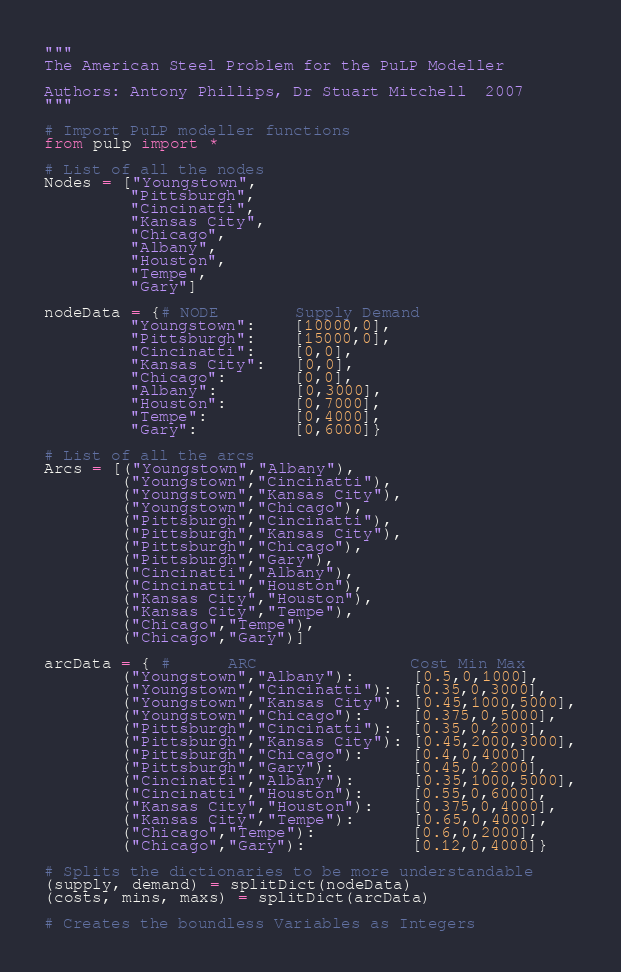Convert code to text. <code><loc_0><loc_0><loc_500><loc_500><_Python_>"""
The American Steel Problem for the PuLP Modeller

Authors: Antony Phillips, Dr Stuart Mitchell  2007
"""

# Import PuLP modeller functions
from pulp import *

# List of all the nodes
Nodes = ["Youngstown",
         "Pittsburgh",
         "Cincinatti",
         "Kansas City",
         "Chicago",
         "Albany",
         "Houston",
         "Tempe",
         "Gary"]

nodeData = {# NODE        Supply Demand
         "Youngstown":    [10000,0],
         "Pittsburgh":    [15000,0],
         "Cincinatti":    [0,0],
         "Kansas City":   [0,0],
         "Chicago":       [0,0],
         "Albany":        [0,3000],
         "Houston":       [0,7000],
         "Tempe":         [0,4000],
         "Gary":          [0,6000]}

# List of all the arcs
Arcs = [("Youngstown","Albany"),
        ("Youngstown","Cincinatti"),
        ("Youngstown","Kansas City"),
        ("Youngstown","Chicago"),
        ("Pittsburgh","Cincinatti"),
        ("Pittsburgh","Kansas City"),
        ("Pittsburgh","Chicago"),
        ("Pittsburgh","Gary"),
        ("Cincinatti","Albany"),
        ("Cincinatti","Houston"),
        ("Kansas City","Houston"),
        ("Kansas City","Tempe"),
        ("Chicago","Tempe"),
        ("Chicago","Gary")]

arcData = { #      ARC                Cost Min Max
        ("Youngstown","Albany"):      [0.5,0,1000],
        ("Youngstown","Cincinatti"):  [0.35,0,3000],
        ("Youngstown","Kansas City"): [0.45,1000,5000],
        ("Youngstown","Chicago"):     [0.375,0,5000],
        ("Pittsburgh","Cincinatti"):  [0.35,0,2000],
        ("Pittsburgh","Kansas City"): [0.45,2000,3000],
        ("Pittsburgh","Chicago"):     [0.4,0,4000],
        ("Pittsburgh","Gary"):        [0.45,0,2000],
        ("Cincinatti","Albany"):      [0.35,1000,5000],
        ("Cincinatti","Houston"):     [0.55,0,6000],
        ("Kansas City","Houston"):    [0.375,0,4000],
        ("Kansas City","Tempe"):      [0.65,0,4000],
        ("Chicago","Tempe"):          [0.6,0,2000],
        ("Chicago","Gary"):           [0.12,0,4000]}

# Splits the dictionaries to be more understandable
(supply, demand) = splitDict(nodeData)
(costs, mins, maxs) = splitDict(arcData)

# Creates the boundless Variables as Integers</code> 